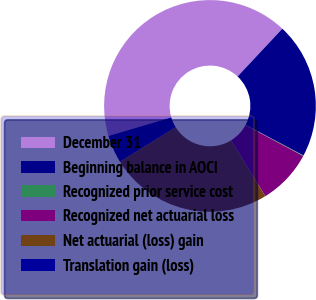Convert chart to OTSL. <chart><loc_0><loc_0><loc_500><loc_500><pie_chart><fcel>December 31<fcel>Beginning balance in AOCI<fcel>Recognized prior service cost<fcel>Recognized net actuarial loss<fcel>Net actuarial (loss) gain<fcel>Translation gain (loss)<nl><fcel>41.55%<fcel>20.78%<fcel>0.1%<fcel>8.39%<fcel>24.93%<fcel>4.25%<nl></chart> 